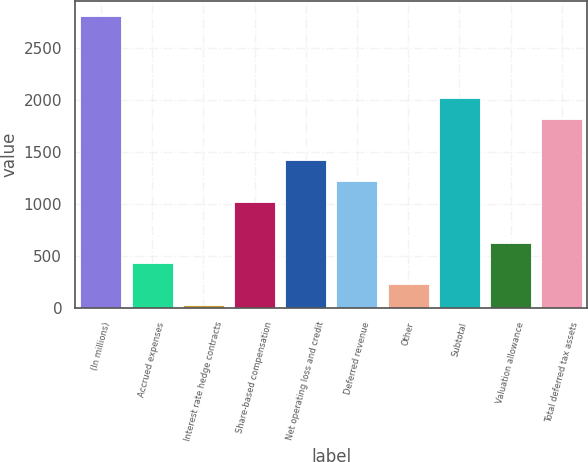<chart> <loc_0><loc_0><loc_500><loc_500><bar_chart><fcel>(In millions)<fcel>Accrued expenses<fcel>Interest rate hedge contracts<fcel>Share-based compensation<fcel>Net operating loss and credit<fcel>Deferred revenue<fcel>Other<fcel>Subtotal<fcel>Valuation allowance<fcel>Total deferred tax assets<nl><fcel>2808.4<fcel>425.2<fcel>28<fcel>1021<fcel>1418.2<fcel>1219.6<fcel>226.6<fcel>2014<fcel>623.8<fcel>1815.4<nl></chart> 